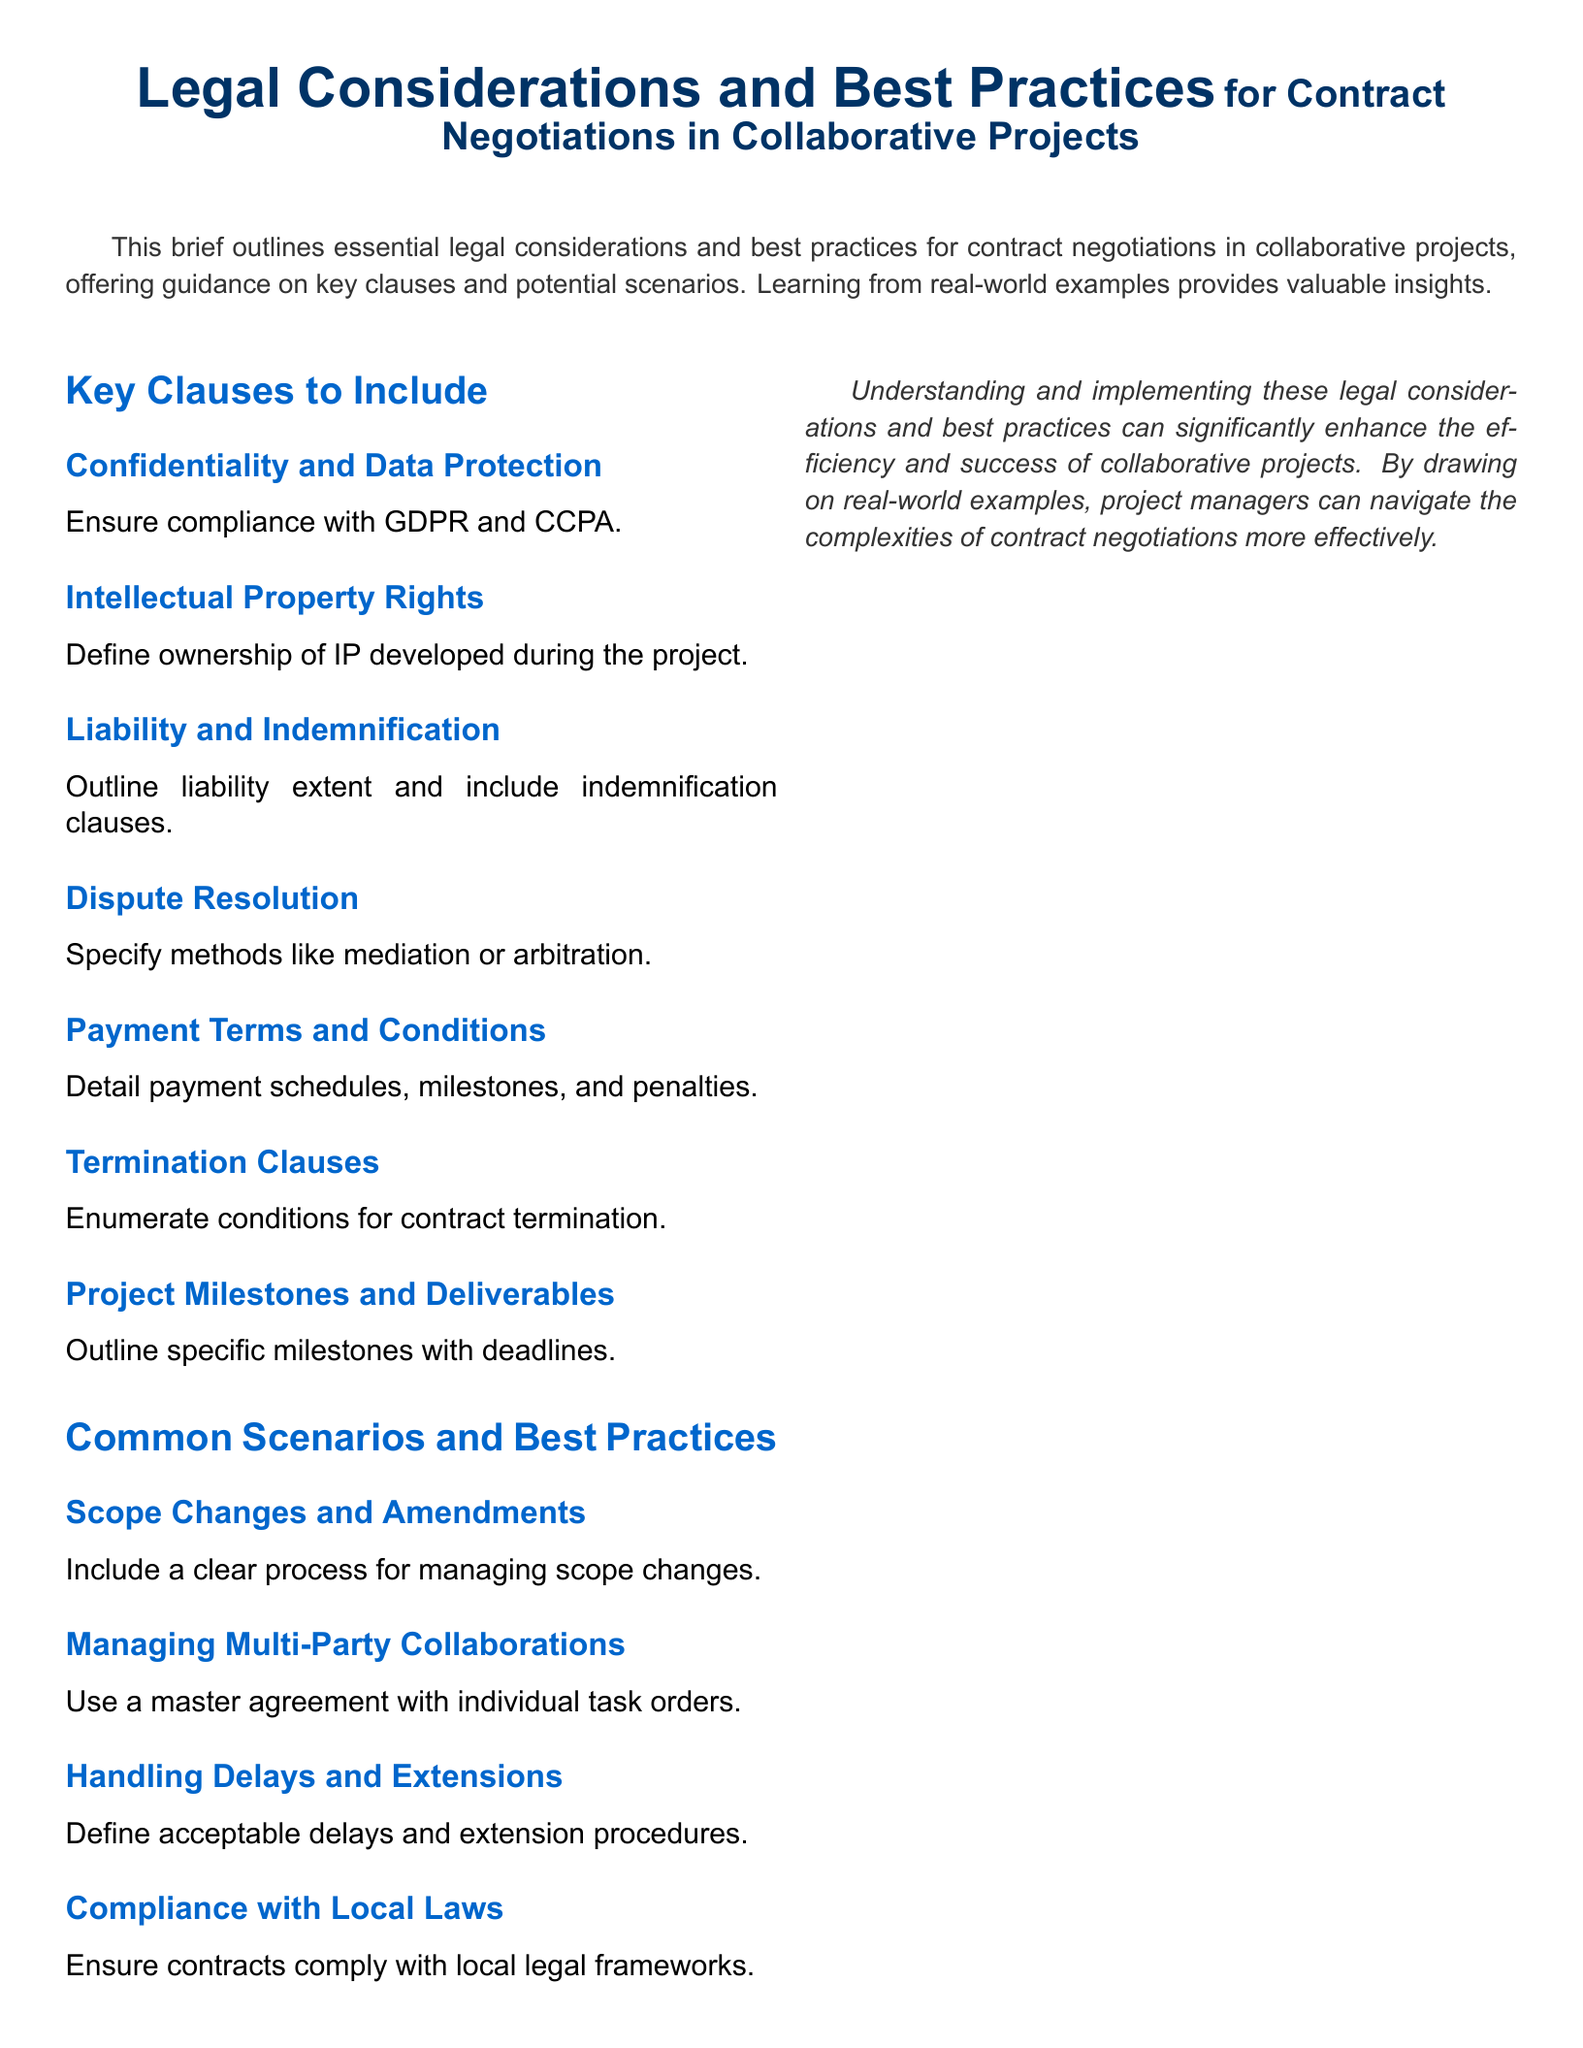What is the primary focus of the brief? The brief outlines essential legal considerations and best practices for contract negotiations in collaborative projects.
Answer: Legal considerations and best practices for contract negotiations Which GDPR principle is mentioned in relation to confidentiality? The document emphasizes the need for compliance with GDPR, a regulation that protects personal data.
Answer: Compliance with GDPR What is one key clause related to intellectual property? The document specifies the need to define ownership of IP developed during the project.
Answer: Ownership of IP Name one method indicated for dispute resolution. The brief suggests specifying methods such as mediation or arbitration for resolving disputes.
Answer: Mediation or arbitration What clause outlines conditions for contract conclusion? The document highlights the importance of termination clauses to enumerate conditions for contract termination.
Answer: Termination clauses In the context of managing multi-party collaborations, what is recommended? The document suggests using a master agreement with individual task orders for managing multi-party collaborations.
Answer: Master agreement with individual task orders What should be defined regarding delays according to the brief? The brief indicates the need to define acceptable delays and extension procedures.
Answer: Acceptable delays and extension procedures Which local compliance aspect is mentioned? The document highlights the necessity to ensure contracts comply with local legal frameworks.
Answer: Compliance with local laws What is a recommended best practice for scope changes? A clear process for managing scope changes is recommended in the brief.
Answer: Clear process for managing scope changes 